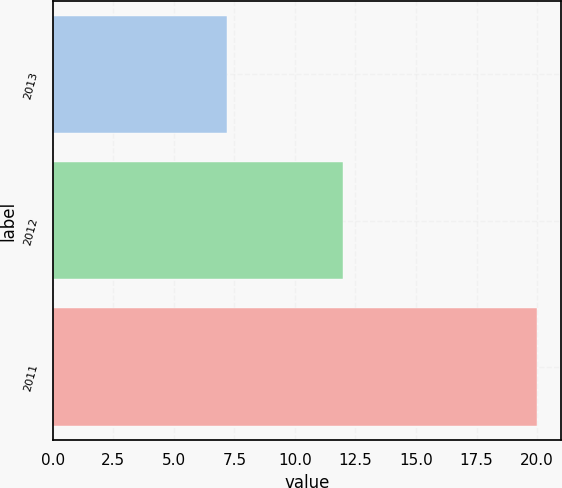<chart> <loc_0><loc_0><loc_500><loc_500><bar_chart><fcel>2013<fcel>2012<fcel>2011<nl><fcel>7.2<fcel>12<fcel>20<nl></chart> 